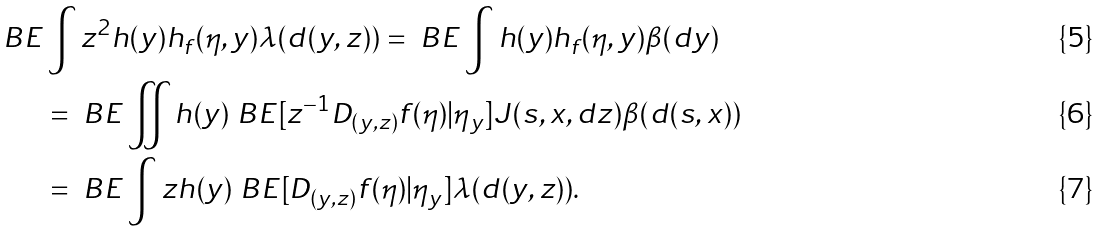<formula> <loc_0><loc_0><loc_500><loc_500>\ B E & \int z ^ { 2 } h ( y ) h _ { f } ( \eta , y ) \lambda ( d ( y , z ) ) = \ B E \int h ( y ) h _ { f } ( \eta , y ) \beta ( d y ) \\ & = \ B E \iint h ( y ) \ B E [ z ^ { - 1 } D _ { ( y , z ) } f ( \eta ) | \eta _ { y } ] J ( s , x , d z ) \beta ( d ( s , x ) ) \\ & = \ B E \int z h ( y ) \ B E [ D _ { ( y , z ) } f ( \eta ) | \eta _ { y } ] \lambda ( d ( y , z ) ) .</formula> 